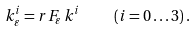<formula> <loc_0><loc_0><loc_500><loc_500>k _ { \varepsilon } ^ { i } = r F _ { \varepsilon } \, k ^ { i } \quad ( i = 0 \dots 3 ) \, .</formula> 